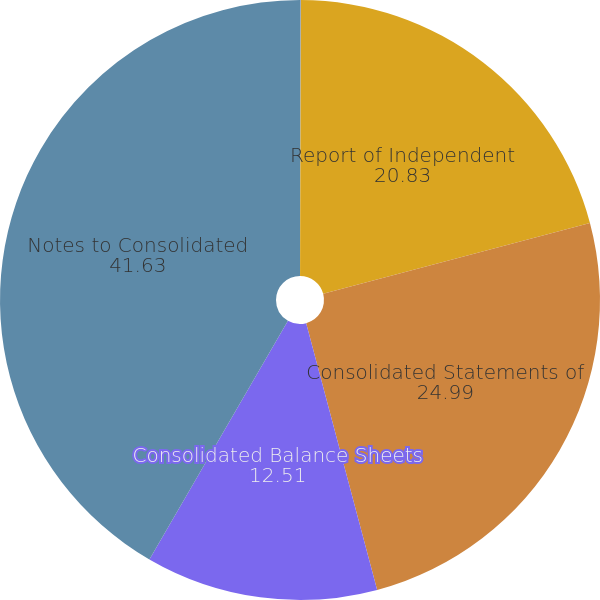<chart> <loc_0><loc_0><loc_500><loc_500><pie_chart><fcel>Management's Report on<fcel>Report of Independent<fcel>Consolidated Statements of<fcel>Consolidated Balance Sheets<fcel>Notes to Consolidated<nl><fcel>0.04%<fcel>20.83%<fcel>24.99%<fcel>12.51%<fcel>41.63%<nl></chart> 